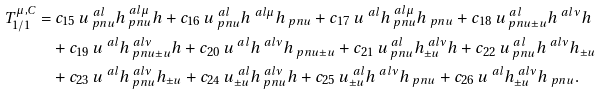<formula> <loc_0><loc_0><loc_500><loc_500>T _ { 1 / 1 } ^ { \mu , C } = & \ c _ { 1 5 } \, u ^ { \ a l } _ { \ p n u } h ^ { \ a l \mu } _ { \ p n u } h + c _ { 1 6 } \, u ^ { \ a l } _ { \ p n u } h ^ { \ a l \mu } h _ { \ p n u } + c _ { 1 7 } \, u ^ { \ a l } h ^ { \ a l \mu } _ { \ p n u } h _ { \ p n u } + c _ { 1 8 } \, u ^ { \ a l } _ { \ p n u \pm u } h ^ { \ a l \nu } h \\ & + c _ { 1 9 } \, u ^ { \ a l } h ^ { \ a l \nu } _ { \ p n u \pm u } h + c _ { 2 0 } \, u ^ { \ a l } h ^ { \ a l \nu } h _ { \ p n u \pm u } + c _ { 2 1 } \, u ^ { \ a l } _ { \ p n u } h ^ { \ a l \nu } _ { \pm u } h + c _ { 2 2 } \, u ^ { \ a l } _ { \ p n u } h ^ { \ a l \nu } h _ { \pm u } \\ & + c _ { 2 3 } \, u ^ { \ a l } h ^ { \ a l \nu } _ { \ p n u } h _ { \pm u } + c _ { 2 4 } \, u ^ { \ a l } _ { \pm u } h ^ { \ a l \nu } _ { \ p n u } h + c _ { 2 5 } \, u ^ { \ a l } _ { \pm u } h ^ { \ a l \nu } h _ { \ p n u } + c _ { 2 6 } \, u ^ { \ a l } h ^ { \ a l \nu } _ { \pm u } h _ { \ p n u } . \\</formula> 